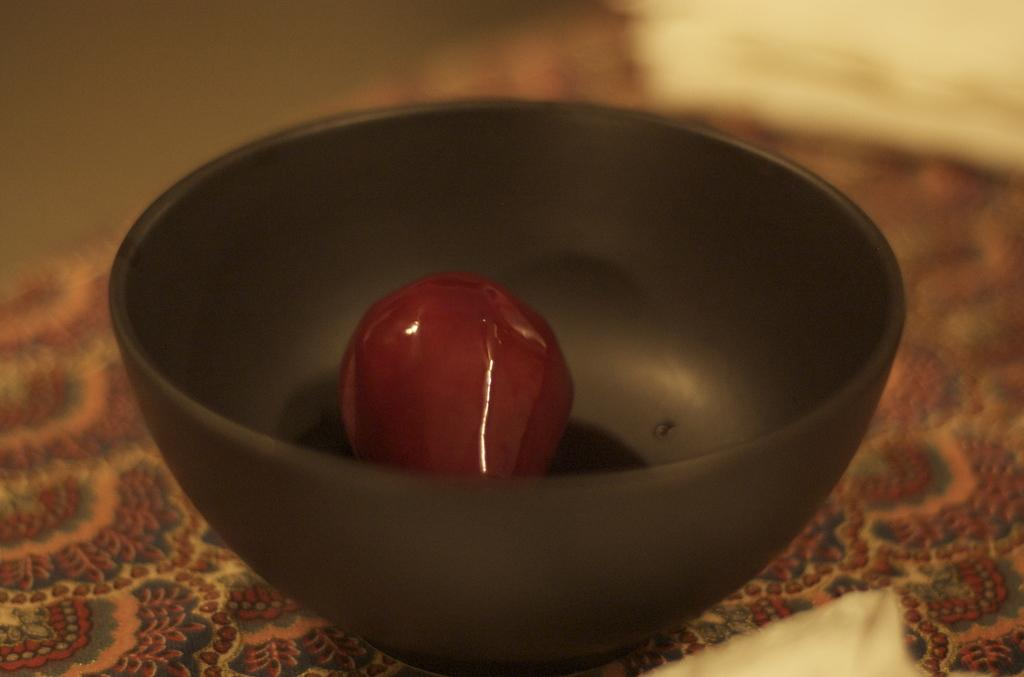What type of fruit is in the image? There is a cherry in the image. What color is the bowl that holds the cherry? The bowl is black in color. Where is the bowl placed? The bowl is placed on a table mat. Can you describe the background of the image? The background of the image is blurred. What type of straw is used by the farmer in the image? There is no farmer or straw present in the image; it only features a cherry in a black bowl placed on a table mat. 